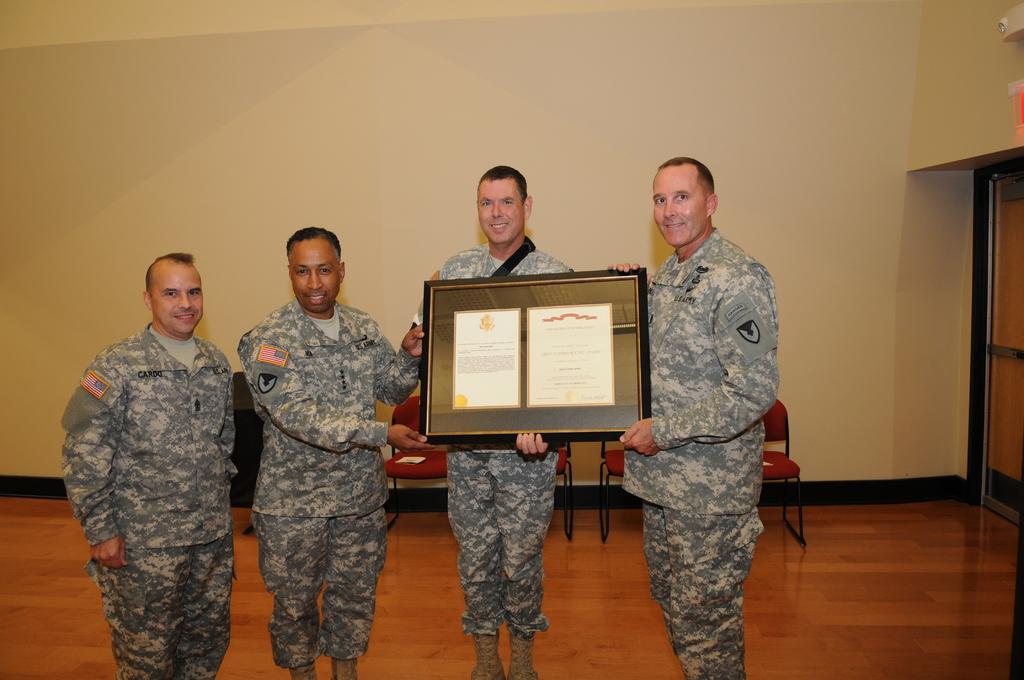In one or two sentences, can you explain what this image depicts? In this picture I can see four persons standing and smiling, there are three persons holding a frame, where there are two certificates in it, and in the background there are chairs, door and there is a wall. 